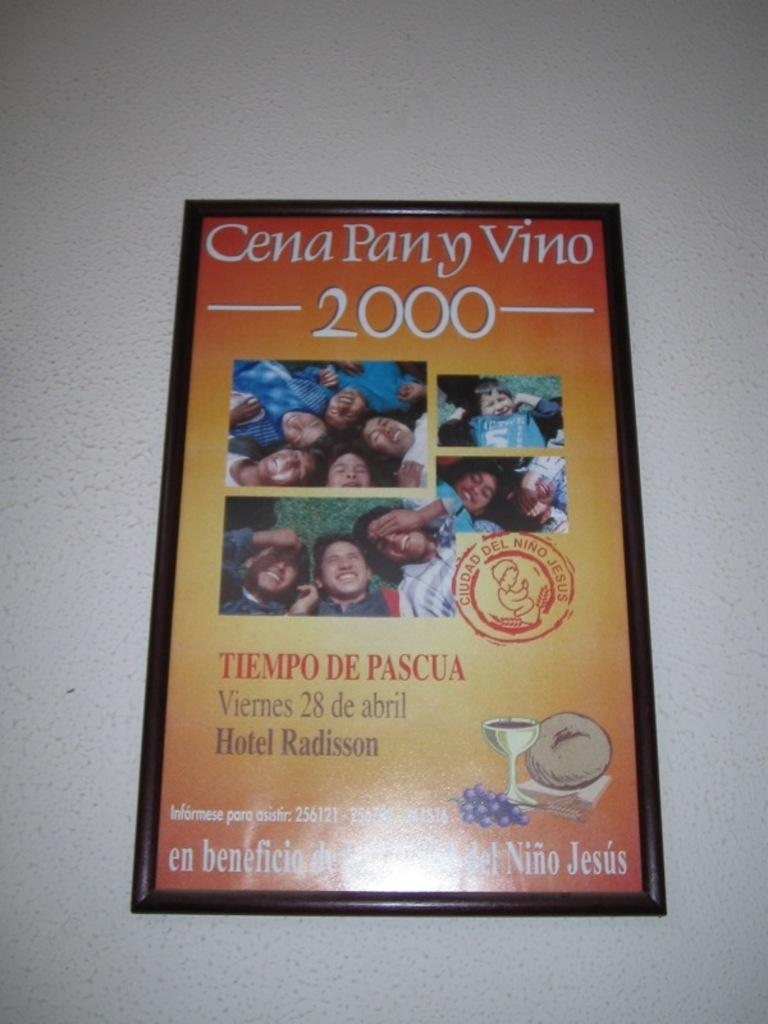<image>
Present a compact description of the photo's key features. Poster framed on a wall that says Cena Pany Vino for year 2000. 